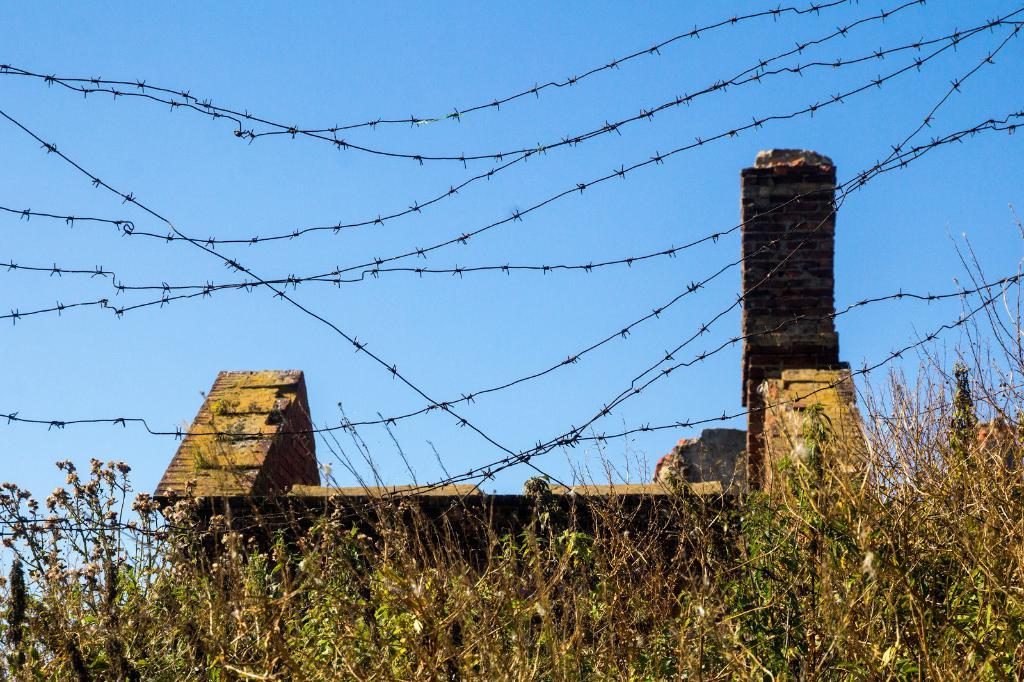What type of vegetation is at the bottom of the image? There are plants at the bottom of the image. What is located in the center of the image? There is a fencing in the center of the image. What type of structure can be seen in the image? There is a house in the image. Where is the pail located in the image? There is no pail present in the image. What type of cat can be seen walking on the fencing in the image? There is no cat present in the image, and therefore no such activity can be observed. 